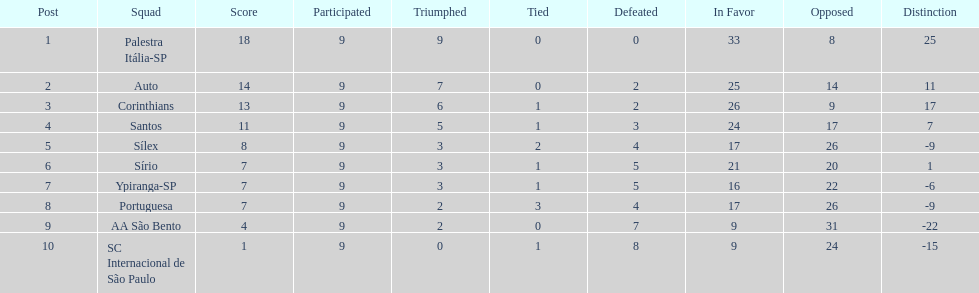During the 1926 football season in brazil, how many points were scored in total? 90. 